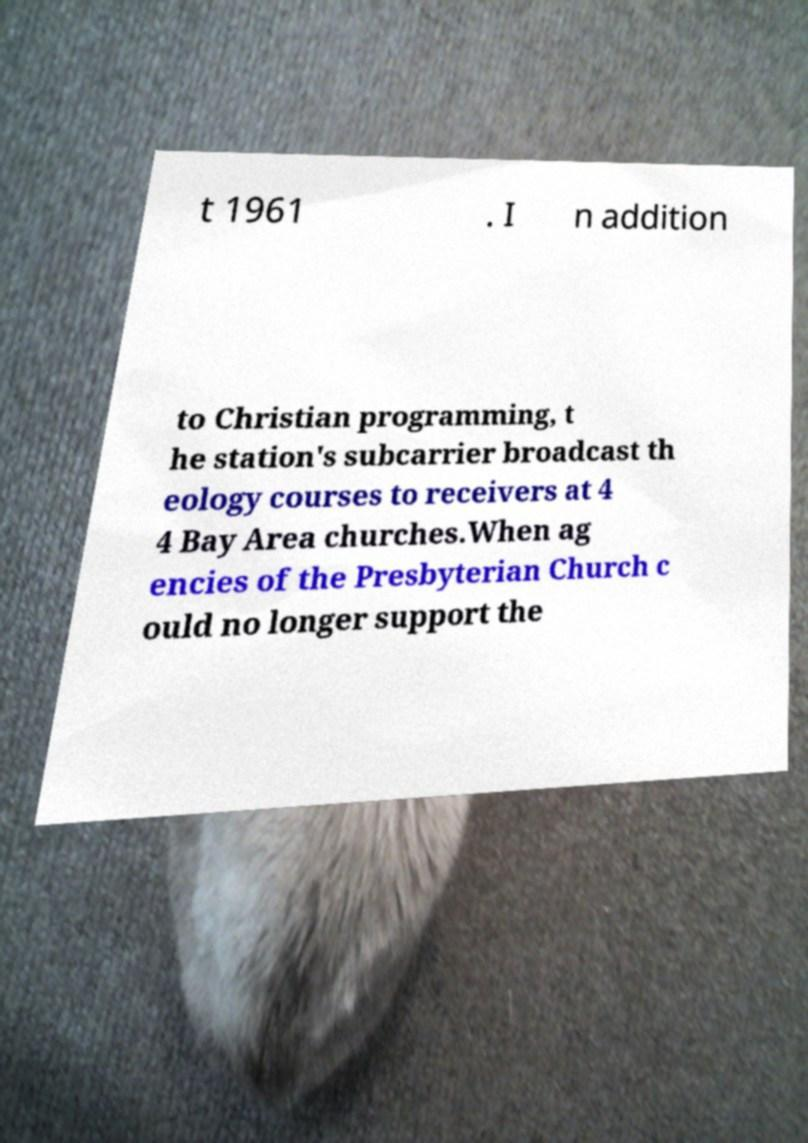I need the written content from this picture converted into text. Can you do that? t 1961 . I n addition to Christian programming, t he station's subcarrier broadcast th eology courses to receivers at 4 4 Bay Area churches.When ag encies of the Presbyterian Church c ould no longer support the 